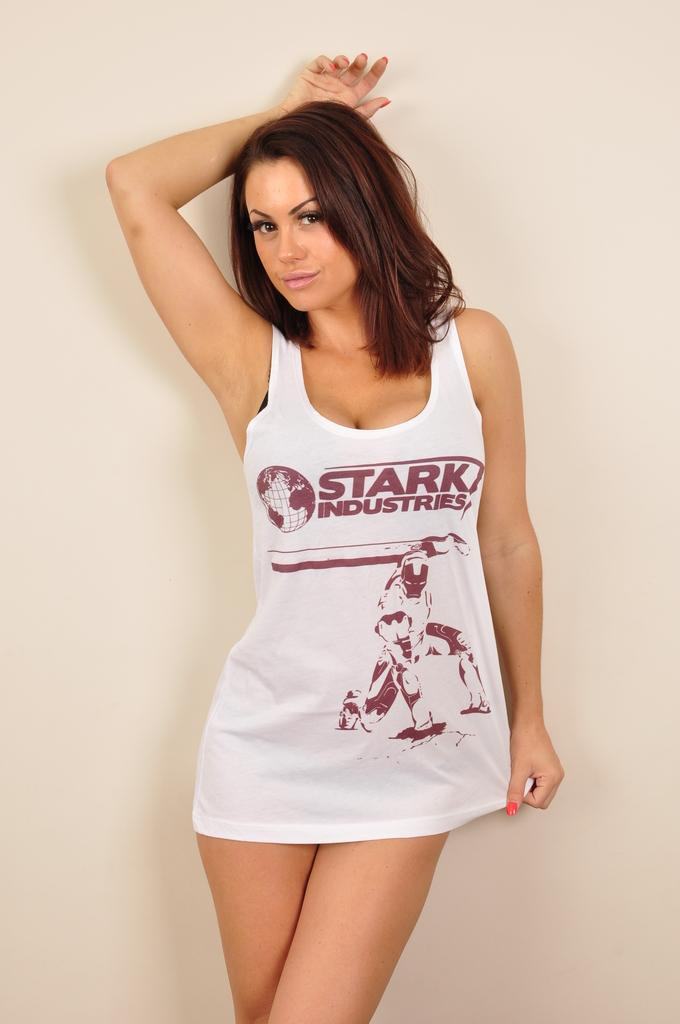<image>
Give a short and clear explanation of the subsequent image. A brown haired woman wearing a "Stark Industries" shirt. 